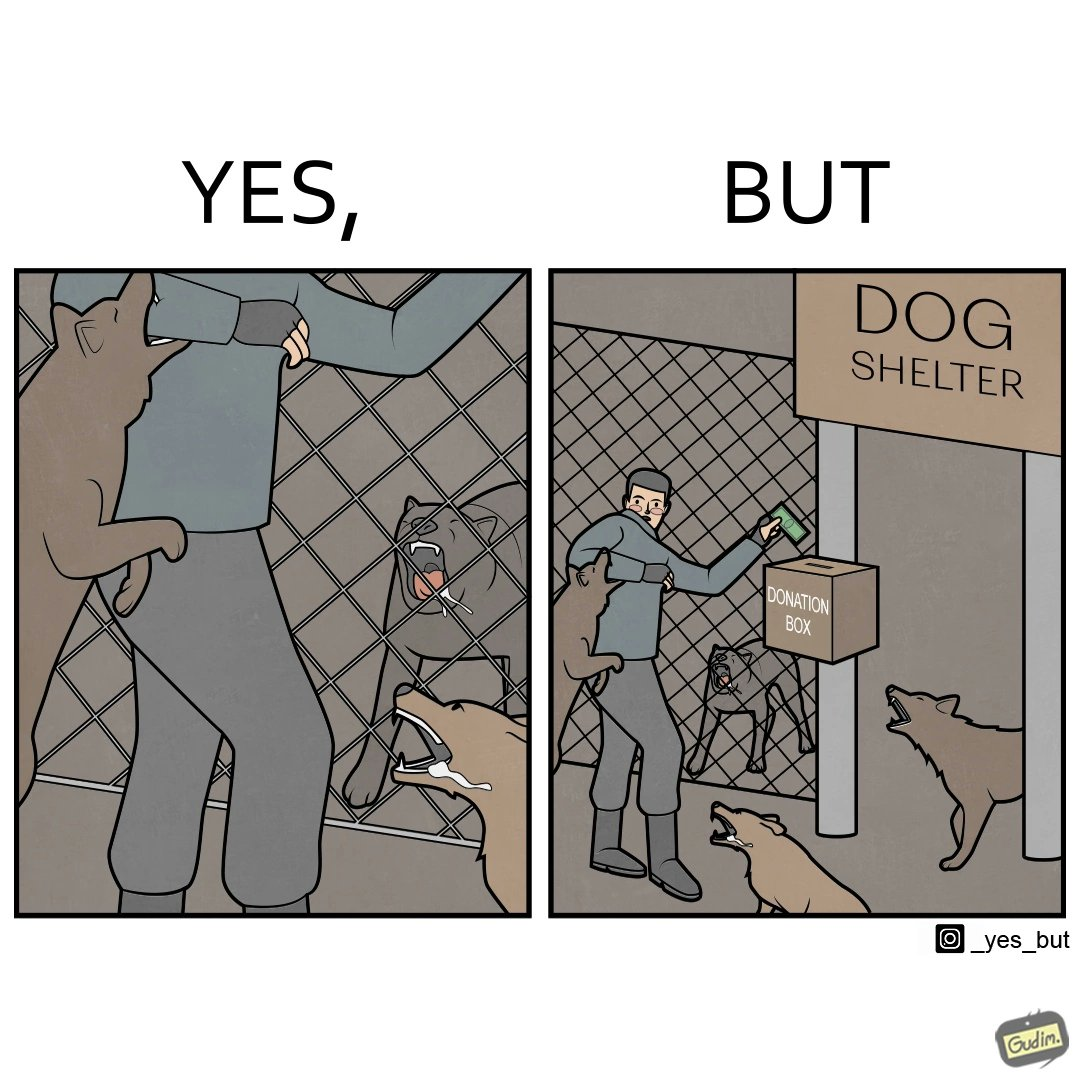Is this a satirical image? Yes, this image is satirical. 